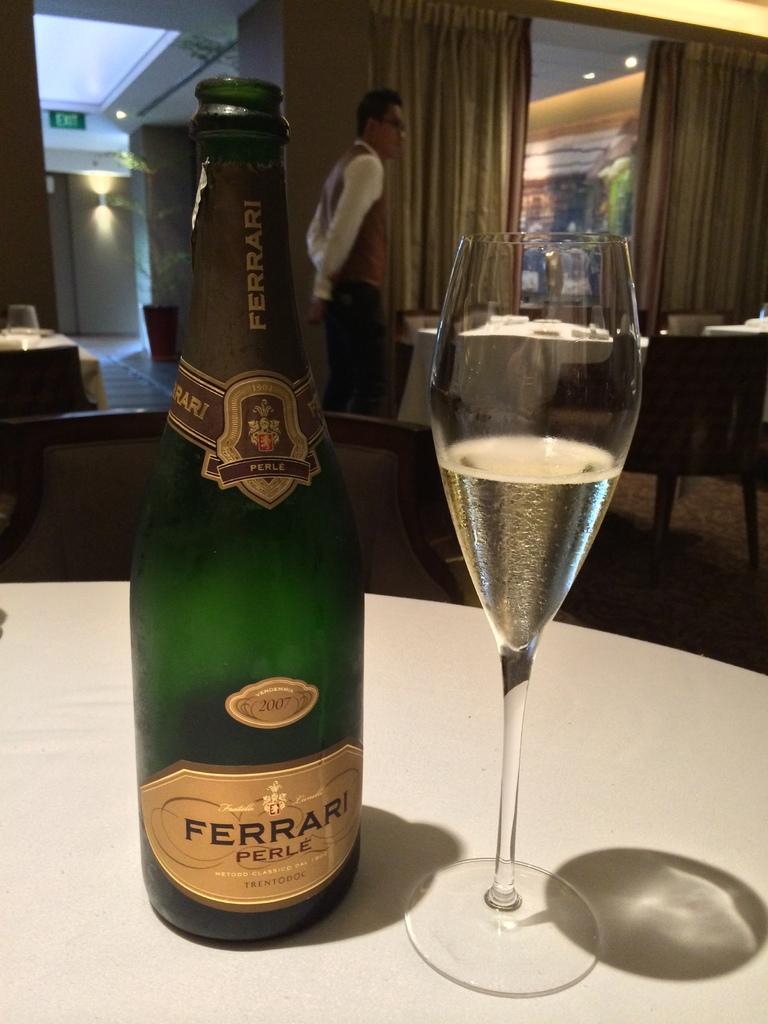In one or two sentences, can you explain what this image depicts? In this picture there is a bottle and a glass on the table in the center. In the background there is a man walking. The restaurant is filled with the tables and chairs. 